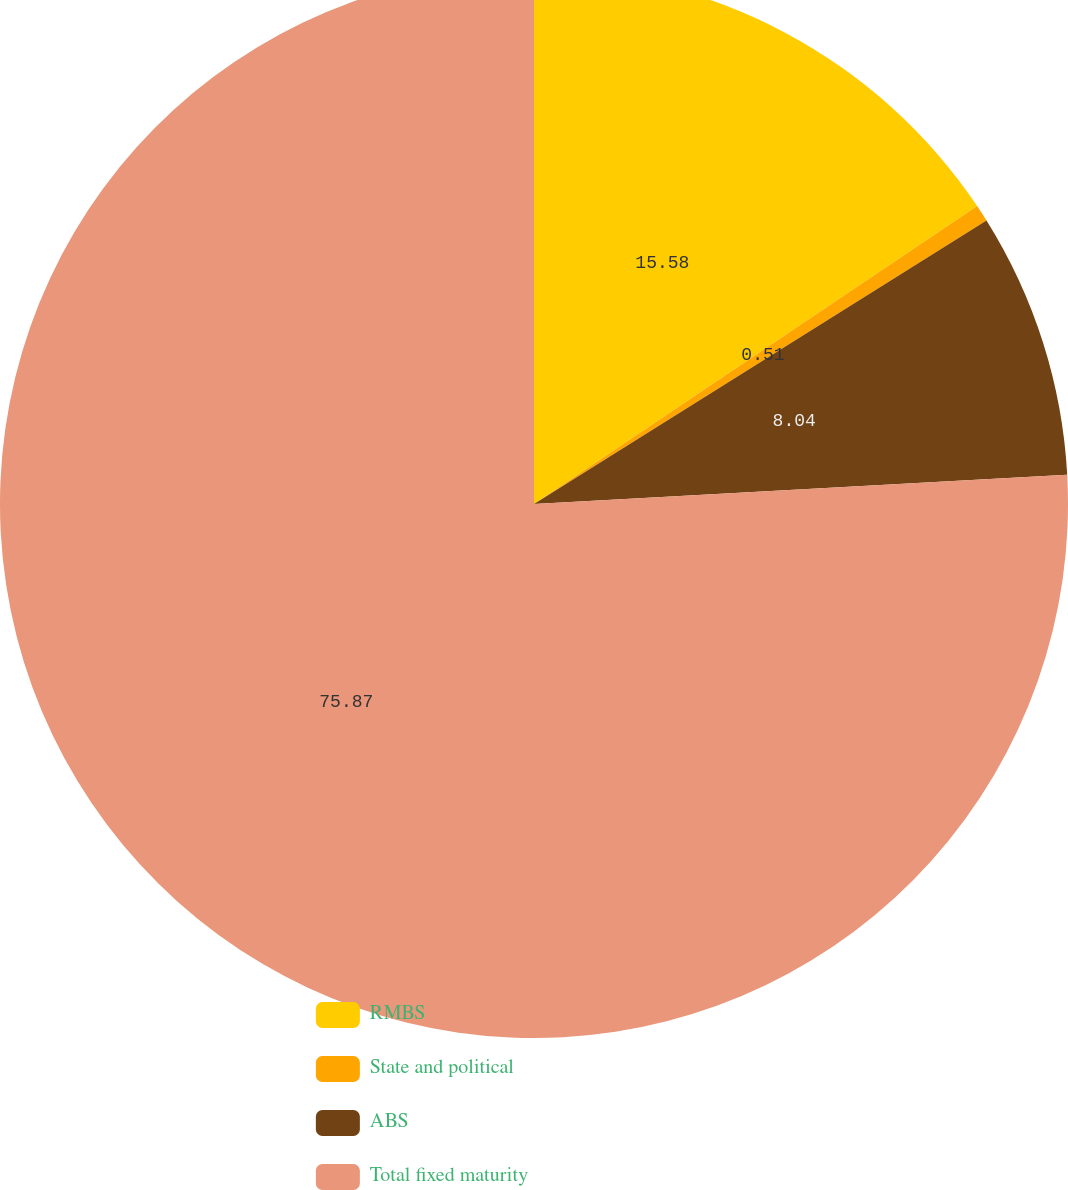<chart> <loc_0><loc_0><loc_500><loc_500><pie_chart><fcel>RMBS<fcel>State and political<fcel>ABS<fcel>Total fixed maturity<nl><fcel>15.58%<fcel>0.51%<fcel>8.04%<fcel>75.87%<nl></chart> 